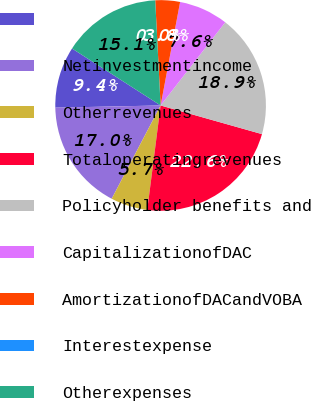Convert chart. <chart><loc_0><loc_0><loc_500><loc_500><pie_chart><ecel><fcel>Netinvestmentincome<fcel>Otherrevenues<fcel>Totaloperatingrevenues<fcel>Policyholder benefits and<fcel>CapitalizationofDAC<fcel>AmortizationofDACandVOBA<fcel>Interestexpense<fcel>Otherexpenses<nl><fcel>9.43%<fcel>16.98%<fcel>5.66%<fcel>22.64%<fcel>18.87%<fcel>7.55%<fcel>3.78%<fcel>0.0%<fcel>15.09%<nl></chart> 